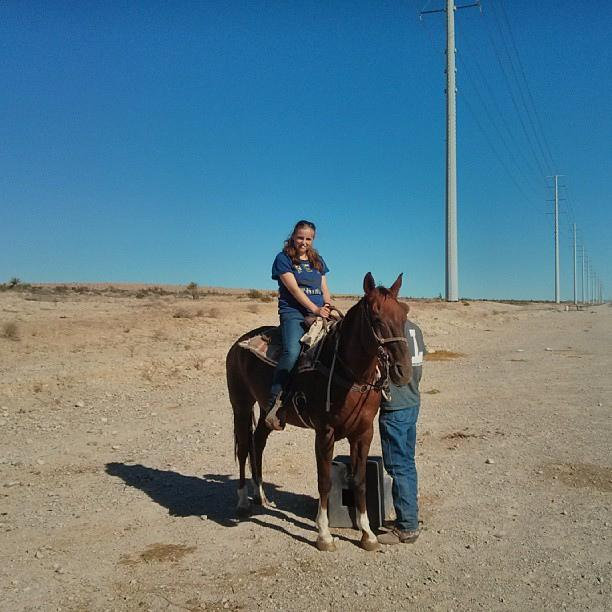If you want to use this transport what can you feed it? hay 